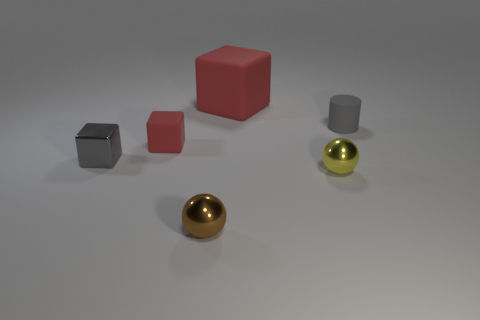Subtract all red rubber blocks. How many blocks are left? 1 Subtract all gray cylinders. How many red cubes are left? 2 Subtract 1 blocks. How many blocks are left? 2 Add 4 gray matte objects. How many objects exist? 10 Subtract all cylinders. How many objects are left? 5 Subtract all brown cubes. Subtract all cyan cylinders. How many cubes are left? 3 Add 5 red objects. How many red objects are left? 7 Add 4 red objects. How many red objects exist? 6 Subtract 0 green cylinders. How many objects are left? 6 Subtract all tiny cyan cubes. Subtract all tiny red matte things. How many objects are left? 5 